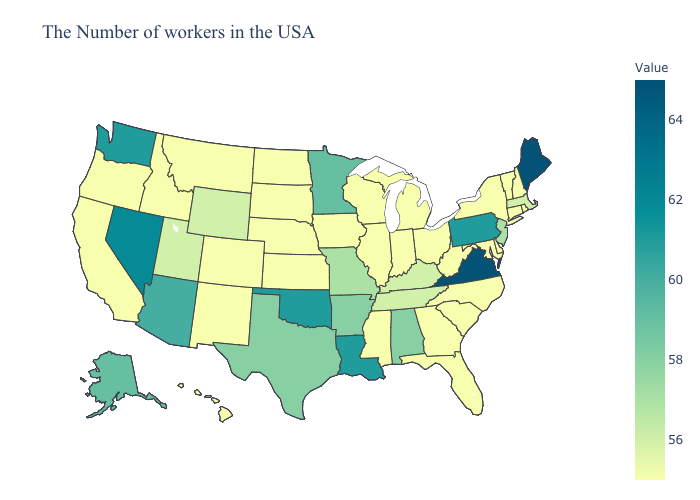Does Rhode Island have the lowest value in the Northeast?
Write a very short answer. Yes. Which states hav the highest value in the South?
Be succinct. Virginia. Does Wyoming have the lowest value in the USA?
Concise answer only. No. Does the map have missing data?
Write a very short answer. No. Does Alabama have the highest value in the South?
Quick response, please. No. Which states hav the highest value in the MidWest?
Keep it brief. Minnesota. 